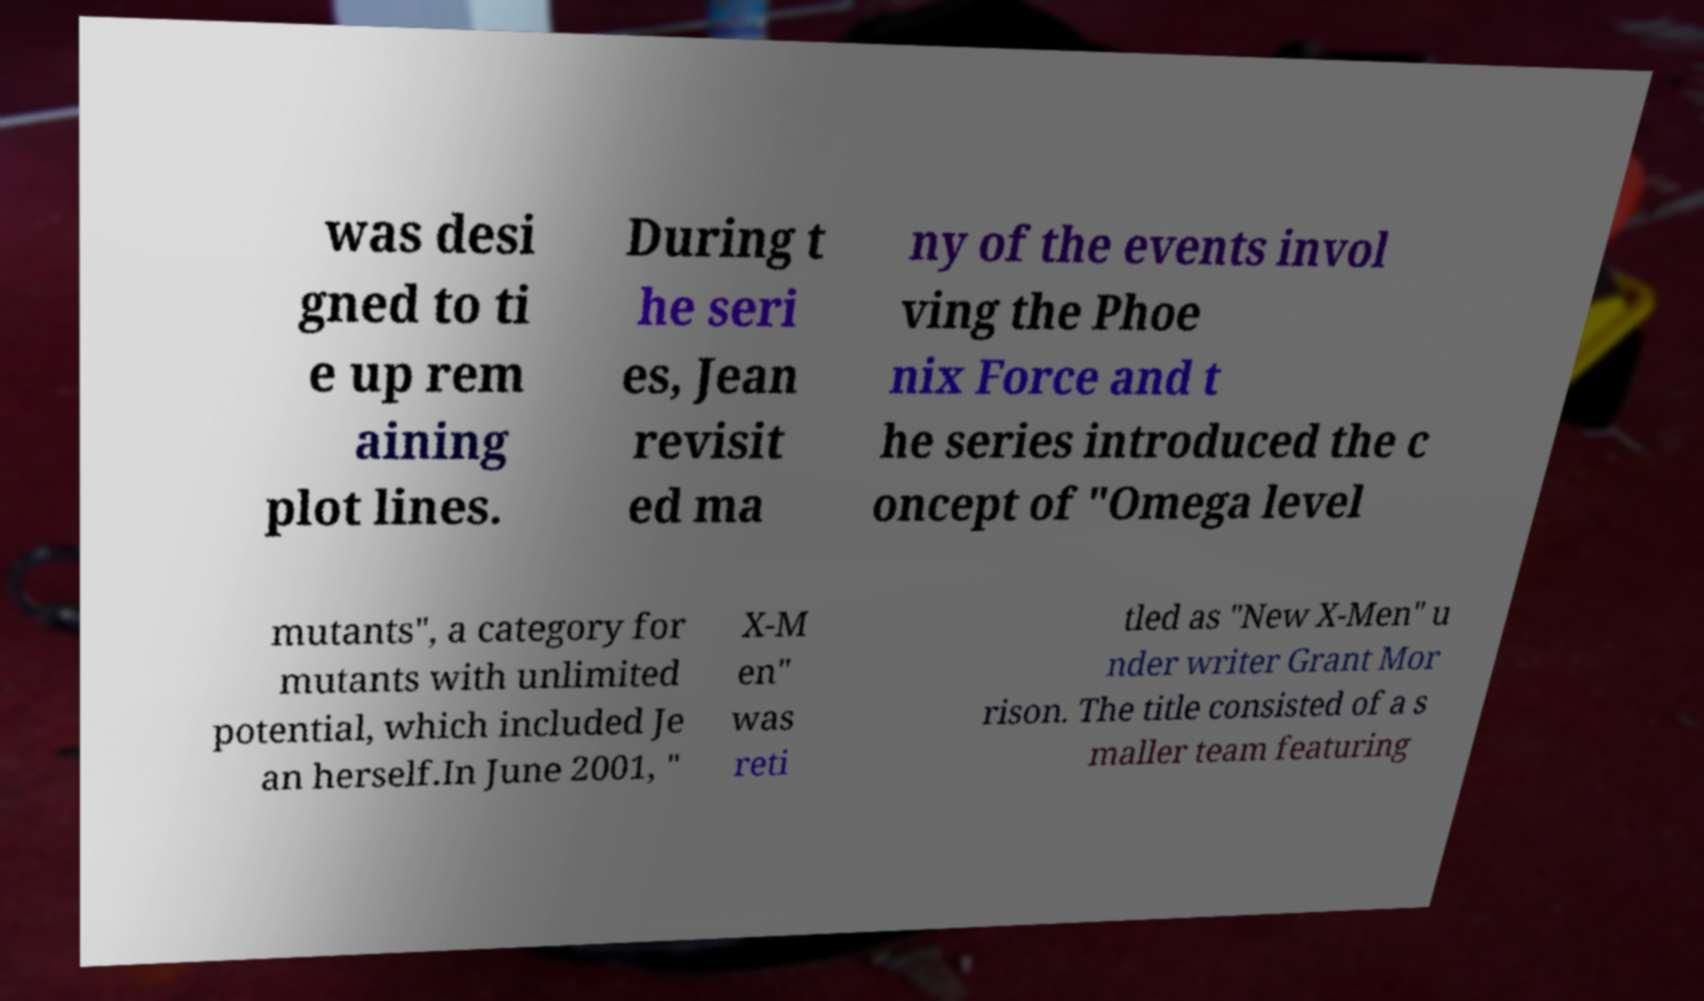I need the written content from this picture converted into text. Can you do that? was desi gned to ti e up rem aining plot lines. During t he seri es, Jean revisit ed ma ny of the events invol ving the Phoe nix Force and t he series introduced the c oncept of "Omega level mutants", a category for mutants with unlimited potential, which included Je an herself.In June 2001, " X-M en" was reti tled as "New X-Men" u nder writer Grant Mor rison. The title consisted of a s maller team featuring 